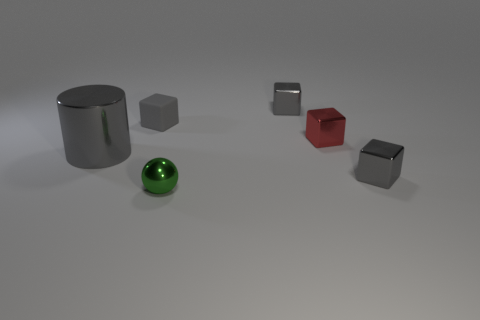Subtract all gray cubes. How many were subtracted if there are1gray cubes left? 2 Subtract all gray cubes. How many cubes are left? 1 Subtract all cylinders. How many objects are left? 5 Subtract 1 balls. How many balls are left? 0 Add 1 green spheres. How many green spheres are left? 2 Add 4 gray metal cubes. How many gray metal cubes exist? 6 Add 1 tiny green shiny spheres. How many objects exist? 7 Subtract all red cubes. How many cubes are left? 3 Subtract 0 yellow cylinders. How many objects are left? 6 Subtract all red cylinders. Subtract all yellow balls. How many cylinders are left? 1 